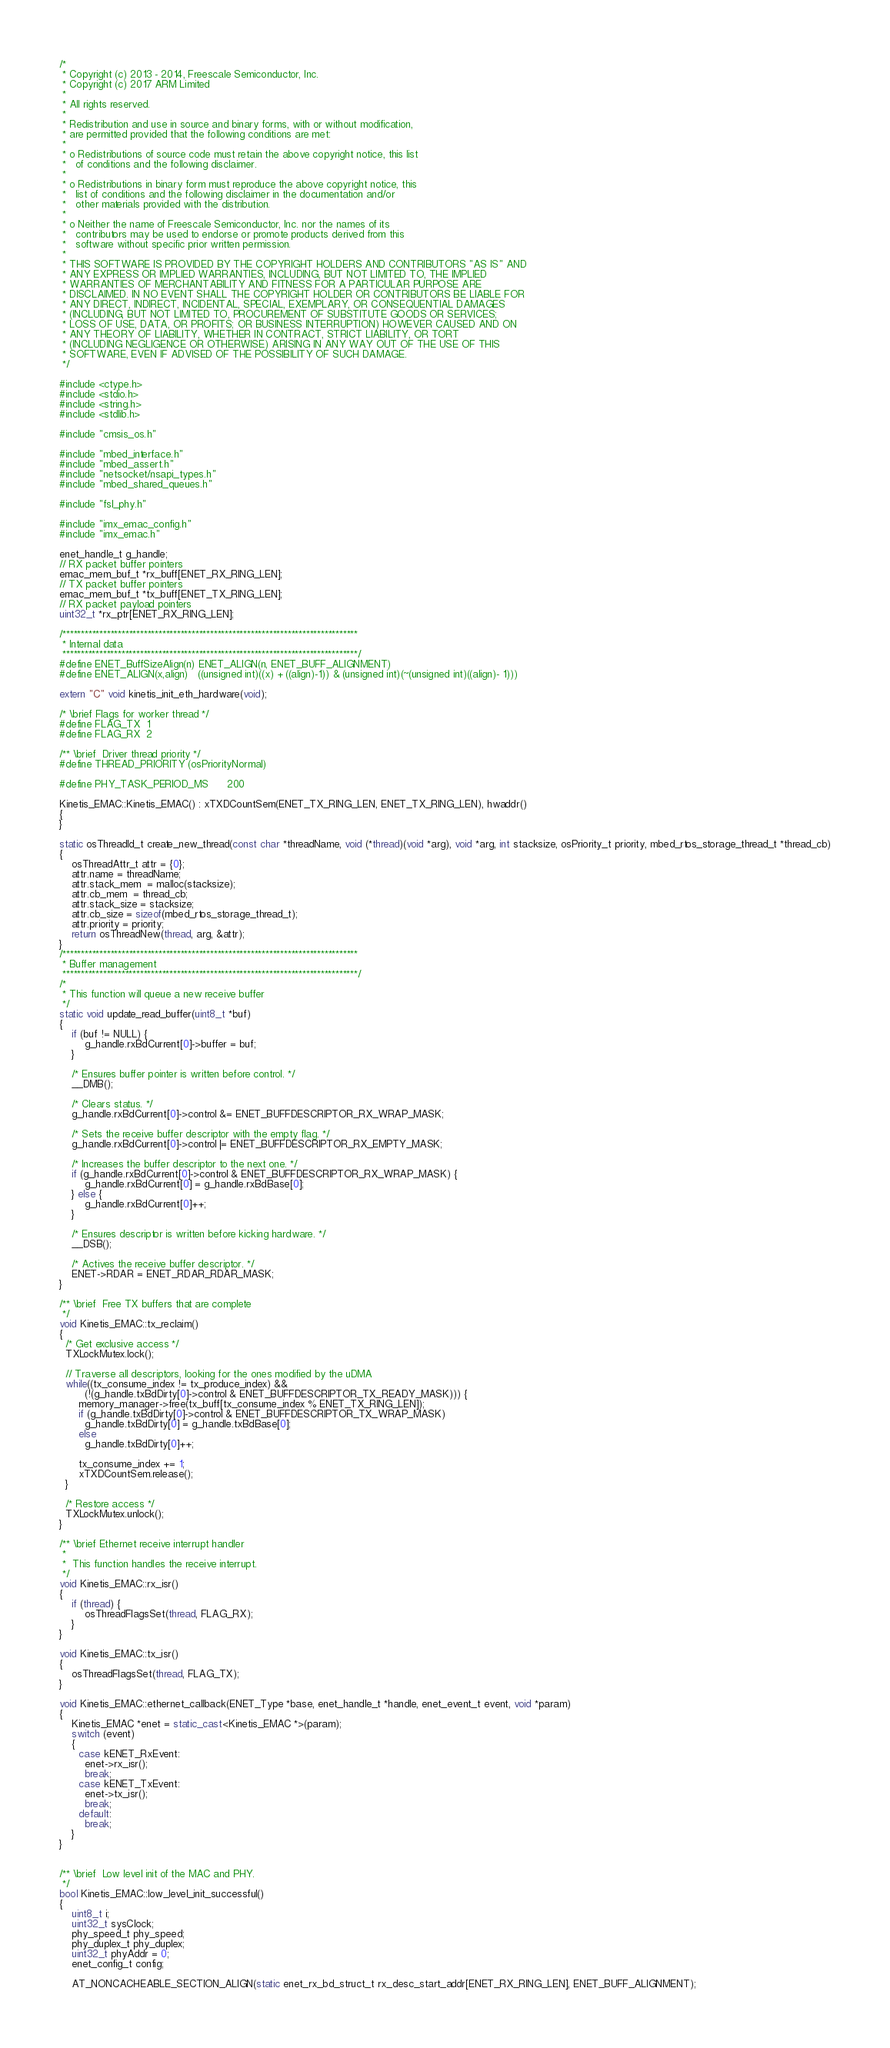Convert code to text. <code><loc_0><loc_0><loc_500><loc_500><_C++_>/*
 * Copyright (c) 2013 - 2014, Freescale Semiconductor, Inc.
 * Copyright (c) 2017 ARM Limited
 *
 * All rights reserved.
 *
 * Redistribution and use in source and binary forms, with or without modification,
 * are permitted provided that the following conditions are met:
 *
 * o Redistributions of source code must retain the above copyright notice, this list
 *   of conditions and the following disclaimer.
 *
 * o Redistributions in binary form must reproduce the above copyright notice, this
 *   list of conditions and the following disclaimer in the documentation and/or
 *   other materials provided with the distribution.
 *
 * o Neither the name of Freescale Semiconductor, Inc. nor the names of its
 *   contributors may be used to endorse or promote products derived from this
 *   software without specific prior written permission.
 *
 * THIS SOFTWARE IS PROVIDED BY THE COPYRIGHT HOLDERS AND CONTRIBUTORS "AS IS" AND
 * ANY EXPRESS OR IMPLIED WARRANTIES, INCLUDING, BUT NOT LIMITED TO, THE IMPLIED
 * WARRANTIES OF MERCHANTABILITY AND FITNESS FOR A PARTICULAR PURPOSE ARE
 * DISCLAIMED. IN NO EVENT SHALL THE COPYRIGHT HOLDER OR CONTRIBUTORS BE LIABLE FOR
 * ANY DIRECT, INDIRECT, INCIDENTAL, SPECIAL, EXEMPLARY, OR CONSEQUENTIAL DAMAGES
 * (INCLUDING, BUT NOT LIMITED TO, PROCUREMENT OF SUBSTITUTE GOODS OR SERVICES;
 * LOSS OF USE, DATA, OR PROFITS; OR BUSINESS INTERRUPTION) HOWEVER CAUSED AND ON
 * ANY THEORY OF LIABILITY, WHETHER IN CONTRACT, STRICT LIABILITY, OR TORT
 * (INCLUDING NEGLIGENCE OR OTHERWISE) ARISING IN ANY WAY OUT OF THE USE OF THIS
 * SOFTWARE, EVEN IF ADVISED OF THE POSSIBILITY OF SUCH DAMAGE.
 */

#include <ctype.h>
#include <stdio.h>
#include <string.h>
#include <stdlib.h>

#include "cmsis_os.h"

#include "mbed_interface.h"
#include "mbed_assert.h"
#include "netsocket/nsapi_types.h"
#include "mbed_shared_queues.h"

#include "fsl_phy.h"

#include "imx_emac_config.h"
#include "imx_emac.h"

enet_handle_t g_handle;
// RX packet buffer pointers
emac_mem_buf_t *rx_buff[ENET_RX_RING_LEN];
// TX packet buffer pointers
emac_mem_buf_t *tx_buff[ENET_TX_RING_LEN];
// RX packet payload pointers
uint32_t *rx_ptr[ENET_RX_RING_LEN];

/********************************************************************************
 * Internal data
 ********************************************************************************/
#define ENET_BuffSizeAlign(n) ENET_ALIGN(n, ENET_BUFF_ALIGNMENT)
#define ENET_ALIGN(x,align)   ((unsigned int)((x) + ((align)-1)) & (unsigned int)(~(unsigned int)((align)- 1)))

extern "C" void kinetis_init_eth_hardware(void);

/* \brief Flags for worker thread */
#define FLAG_TX  1
#define FLAG_RX  2

/** \brief  Driver thread priority */
#define THREAD_PRIORITY (osPriorityNormal)

#define PHY_TASK_PERIOD_MS      200

Kinetis_EMAC::Kinetis_EMAC() : xTXDCountSem(ENET_TX_RING_LEN, ENET_TX_RING_LEN), hwaddr()
{
}

static osThreadId_t create_new_thread(const char *threadName, void (*thread)(void *arg), void *arg, int stacksize, osPriority_t priority, mbed_rtos_storage_thread_t *thread_cb)
{
    osThreadAttr_t attr = {0};
    attr.name = threadName;
    attr.stack_mem  = malloc(stacksize);
    attr.cb_mem  = thread_cb;
    attr.stack_size = stacksize;
    attr.cb_size = sizeof(mbed_rtos_storage_thread_t);
    attr.priority = priority;
    return osThreadNew(thread, arg, &attr);
}
/********************************************************************************
 * Buffer management
 ********************************************************************************/
/*
 * This function will queue a new receive buffer
 */
static void update_read_buffer(uint8_t *buf)
{
    if (buf != NULL) {
        g_handle.rxBdCurrent[0]->buffer = buf;
    }

    /* Ensures buffer pointer is written before control. */
    __DMB();

    /* Clears status. */
    g_handle.rxBdCurrent[0]->control &= ENET_BUFFDESCRIPTOR_RX_WRAP_MASK;

    /* Sets the receive buffer descriptor with the empty flag. */
    g_handle.rxBdCurrent[0]->control |= ENET_BUFFDESCRIPTOR_RX_EMPTY_MASK;

    /* Increases the buffer descriptor to the next one. */
    if (g_handle.rxBdCurrent[0]->control & ENET_BUFFDESCRIPTOR_RX_WRAP_MASK) {
        g_handle.rxBdCurrent[0] = g_handle.rxBdBase[0];
    } else {
        g_handle.rxBdCurrent[0]++;
    }

    /* Ensures descriptor is written before kicking hardware. */
    __DSB();

    /* Actives the receive buffer descriptor. */
    ENET->RDAR = ENET_RDAR_RDAR_MASK;
}

/** \brief  Free TX buffers that are complete
 */
void Kinetis_EMAC::tx_reclaim()
{
  /* Get exclusive access */
  TXLockMutex.lock();

  // Traverse all descriptors, looking for the ones modified by the uDMA
  while((tx_consume_index != tx_produce_index) &&
        (!(g_handle.txBdDirty[0]->control & ENET_BUFFDESCRIPTOR_TX_READY_MASK))) {
      memory_manager->free(tx_buff[tx_consume_index % ENET_TX_RING_LEN]);
      if (g_handle.txBdDirty[0]->control & ENET_BUFFDESCRIPTOR_TX_WRAP_MASK)
        g_handle.txBdDirty[0] = g_handle.txBdBase[0];
      else
        g_handle.txBdDirty[0]++;

      tx_consume_index += 1;
      xTXDCountSem.release();
  }

  /* Restore access */
  TXLockMutex.unlock();
}

/** \brief Ethernet receive interrupt handler
 *
 *  This function handles the receive interrupt.
 */
void Kinetis_EMAC::rx_isr()
{
    if (thread) {
        osThreadFlagsSet(thread, FLAG_RX);
    }
}

void Kinetis_EMAC::tx_isr()
{
    osThreadFlagsSet(thread, FLAG_TX);
}

void Kinetis_EMAC::ethernet_callback(ENET_Type *base, enet_handle_t *handle, enet_event_t event, void *param)
{
    Kinetis_EMAC *enet = static_cast<Kinetis_EMAC *>(param);
    switch (event)
    {
      case kENET_RxEvent:
        enet->rx_isr();
        break;
      case kENET_TxEvent:
        enet->tx_isr();
        break;
      default:
        break;
    }
}


/** \brief  Low level init of the MAC and PHY.
 */
bool Kinetis_EMAC::low_level_init_successful()
{
    uint8_t i;
    uint32_t sysClock;
    phy_speed_t phy_speed;
    phy_duplex_t phy_duplex;
    uint32_t phyAddr = 0;
    enet_config_t config;

    AT_NONCACHEABLE_SECTION_ALIGN(static enet_rx_bd_struct_t rx_desc_start_addr[ENET_RX_RING_LEN], ENET_BUFF_ALIGNMENT);</code> 